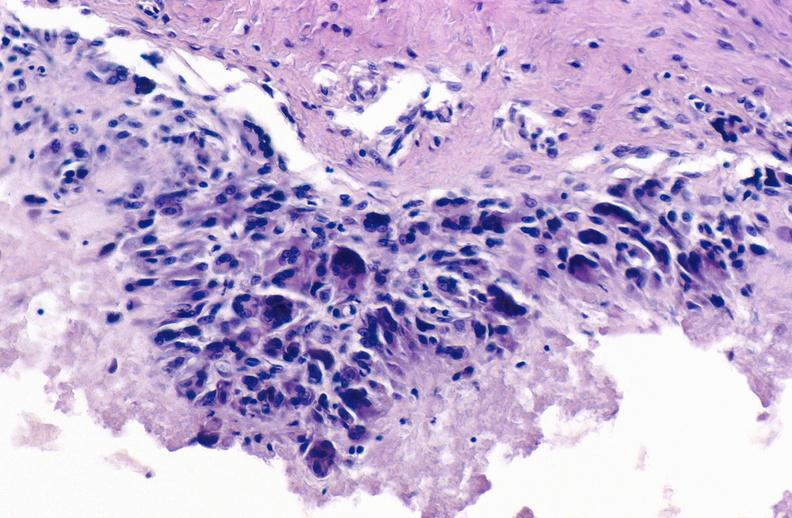does chronic myelogenous leukemia in blast crisis show gout?
Answer the question using a single word or phrase. No 